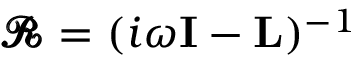Convert formula to latex. <formula><loc_0><loc_0><loc_500><loc_500>\pm b { \mathcal { R } } = ( i \omega I - L ) ^ { - 1 }</formula> 